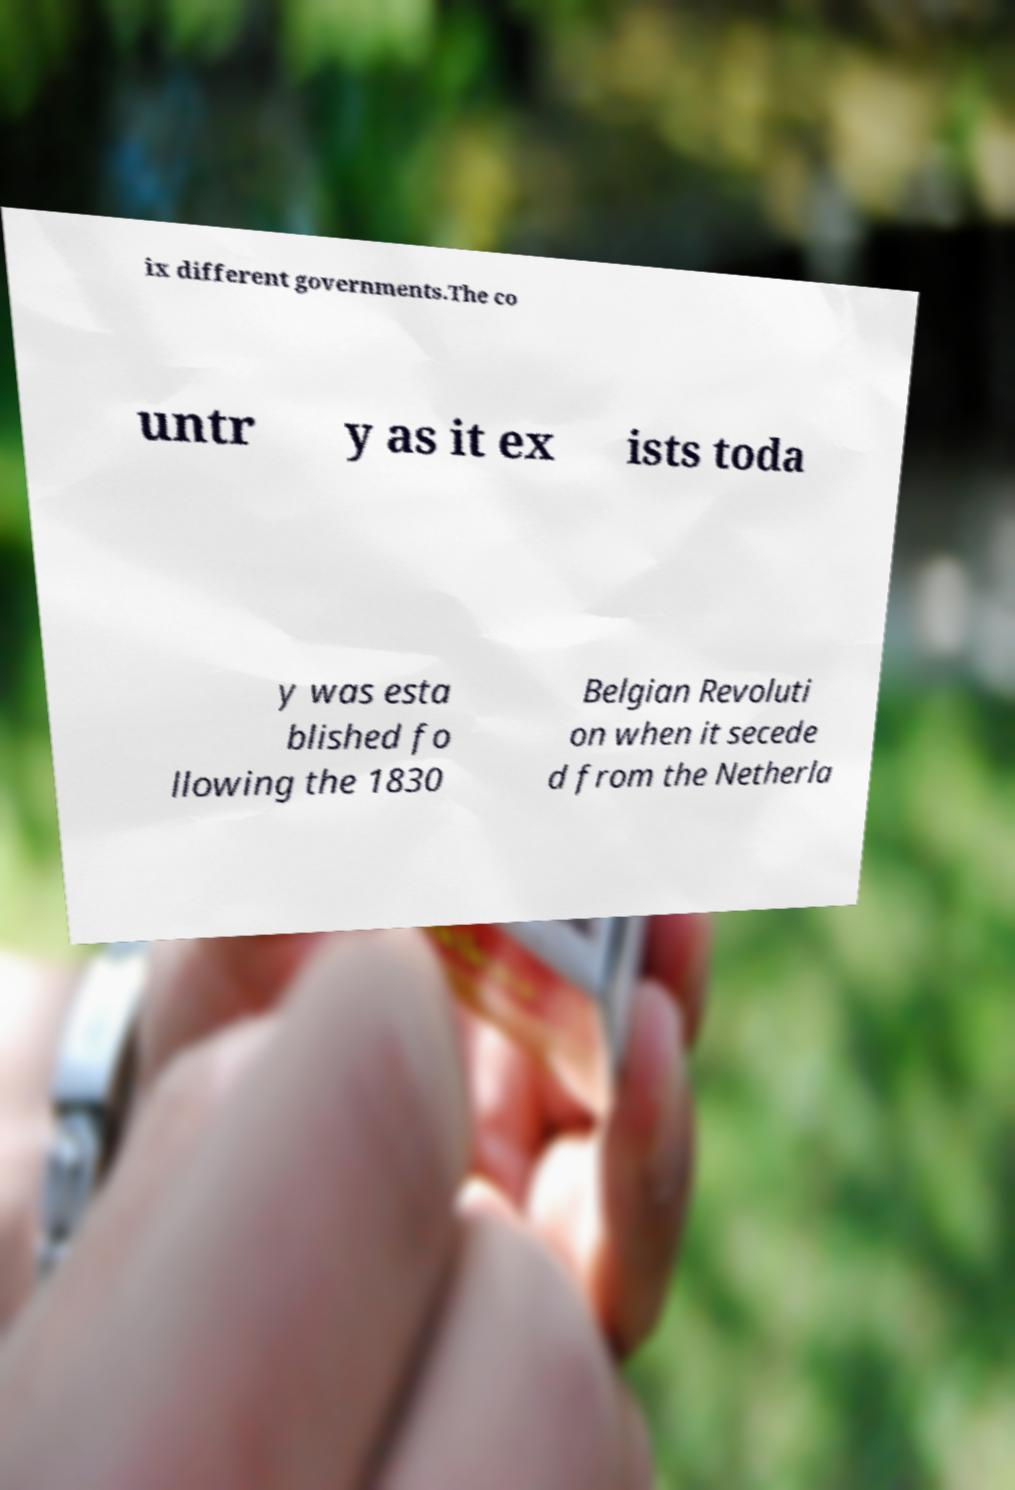There's text embedded in this image that I need extracted. Can you transcribe it verbatim? ix different governments.The co untr y as it ex ists toda y was esta blished fo llowing the 1830 Belgian Revoluti on when it secede d from the Netherla 